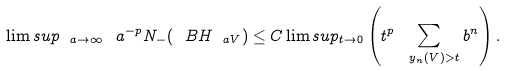Convert formula to latex. <formula><loc_0><loc_0><loc_500><loc_500>\lim s u p _ { \ a \to \infty } \ a ^ { - p } N _ { - } ( \ B H _ { \ a V } ) \leq C \lim s u p _ { t \to 0 } \left ( t ^ { p } \sum _ { \ y _ { n } ( V ) > t } b ^ { n } \right ) .</formula> 